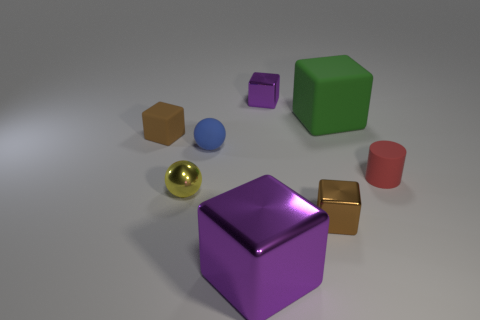Add 1 big cubes. How many objects exist? 9 Subtract all tiny brown shiny blocks. How many blocks are left? 4 Subtract 4 blocks. How many blocks are left? 1 Subtract all blue balls. How many balls are left? 1 Subtract all spheres. How many objects are left? 6 Subtract all cyan cubes. Subtract all yellow balls. How many cubes are left? 5 Subtract all yellow blocks. How many blue spheres are left? 1 Subtract all big rubber things. Subtract all big yellow cylinders. How many objects are left? 7 Add 4 metallic cubes. How many metallic cubes are left? 7 Add 4 big cyan matte balls. How many big cyan matte balls exist? 4 